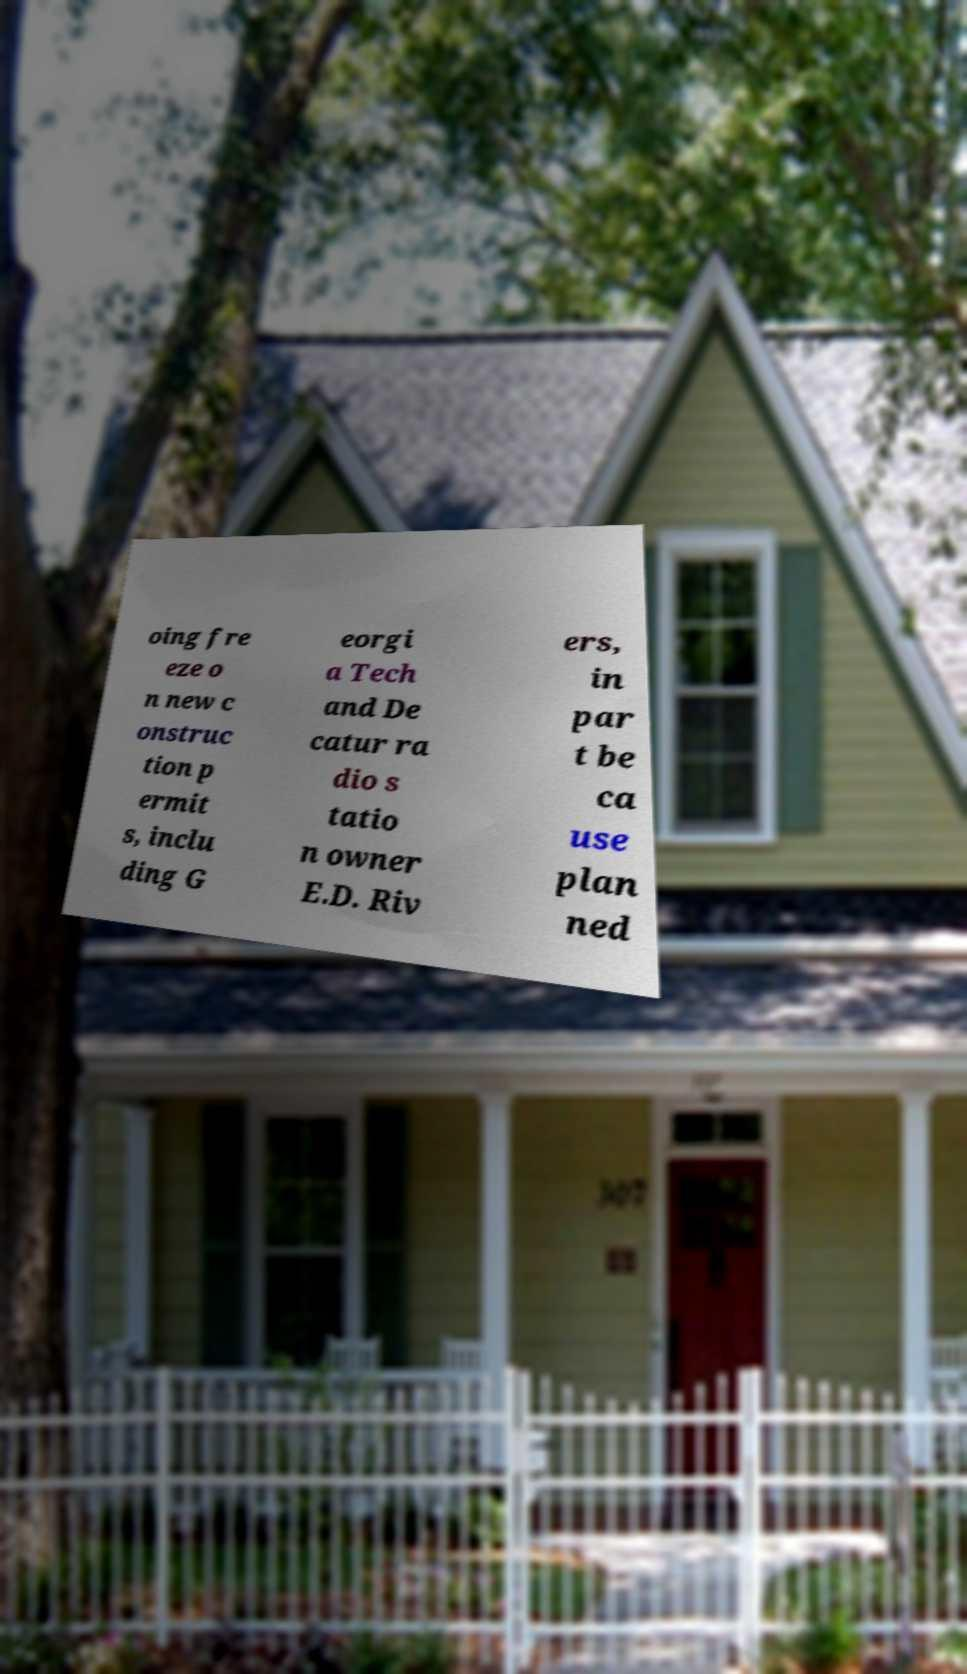There's text embedded in this image that I need extracted. Can you transcribe it verbatim? oing fre eze o n new c onstruc tion p ermit s, inclu ding G eorgi a Tech and De catur ra dio s tatio n owner E.D. Riv ers, in par t be ca use plan ned 